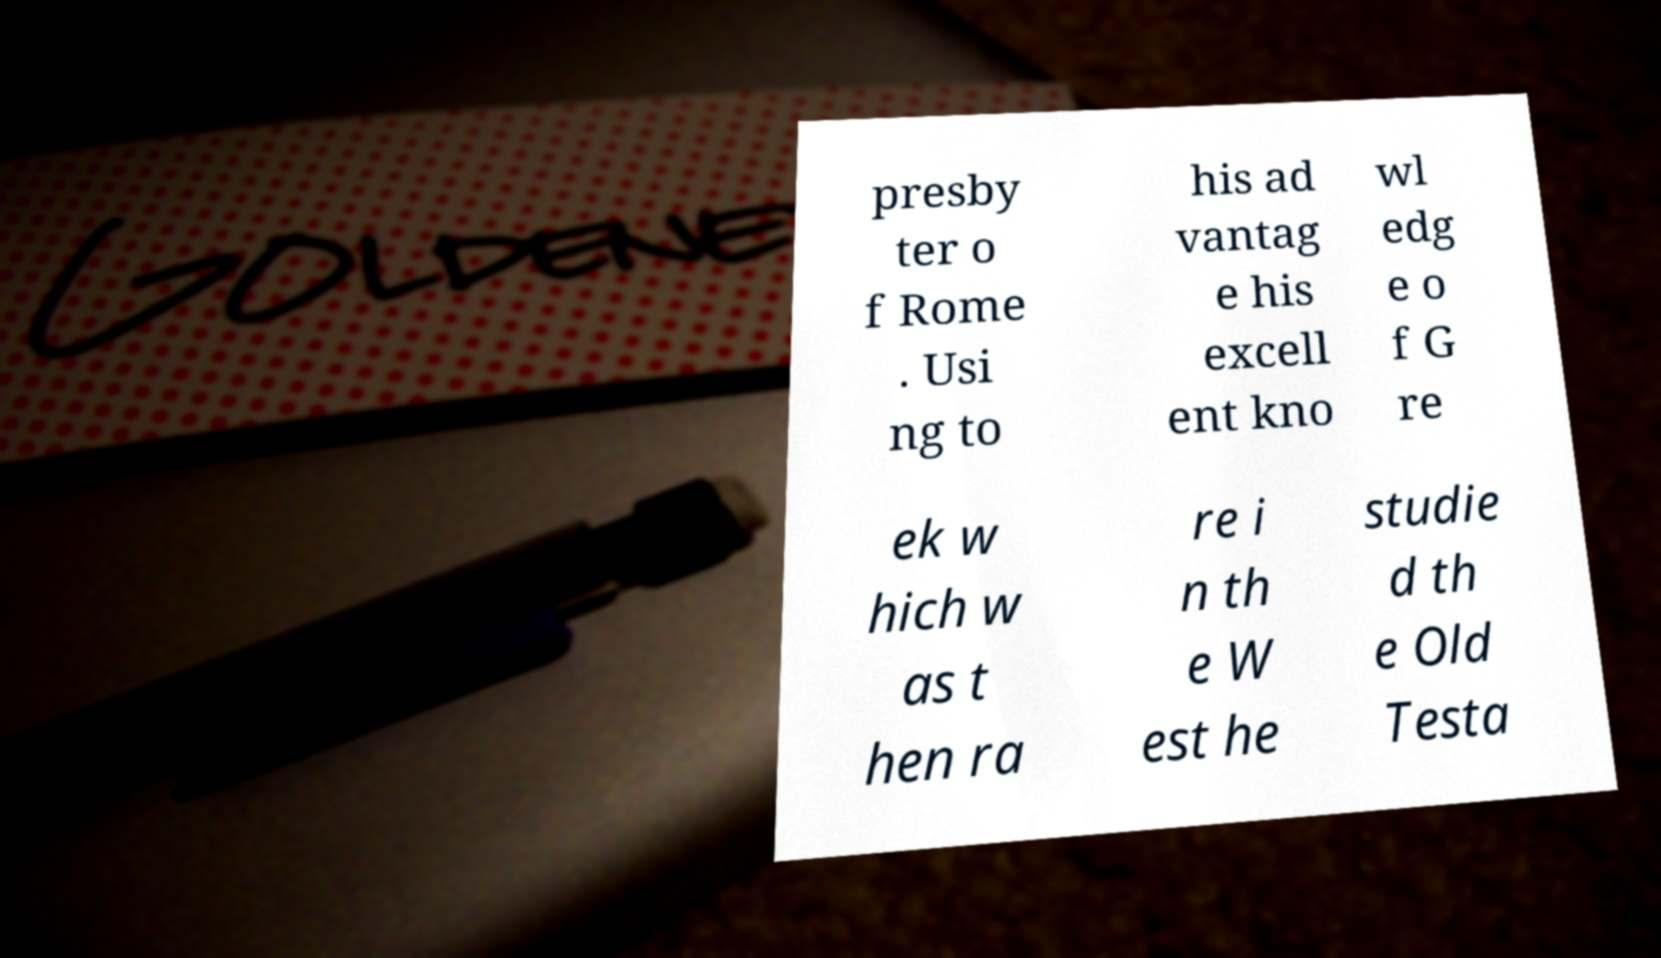What messages or text are displayed in this image? I need them in a readable, typed format. presby ter o f Rome . Usi ng to his ad vantag e his excell ent kno wl edg e o f G re ek w hich w as t hen ra re i n th e W est he studie d th e Old Testa 